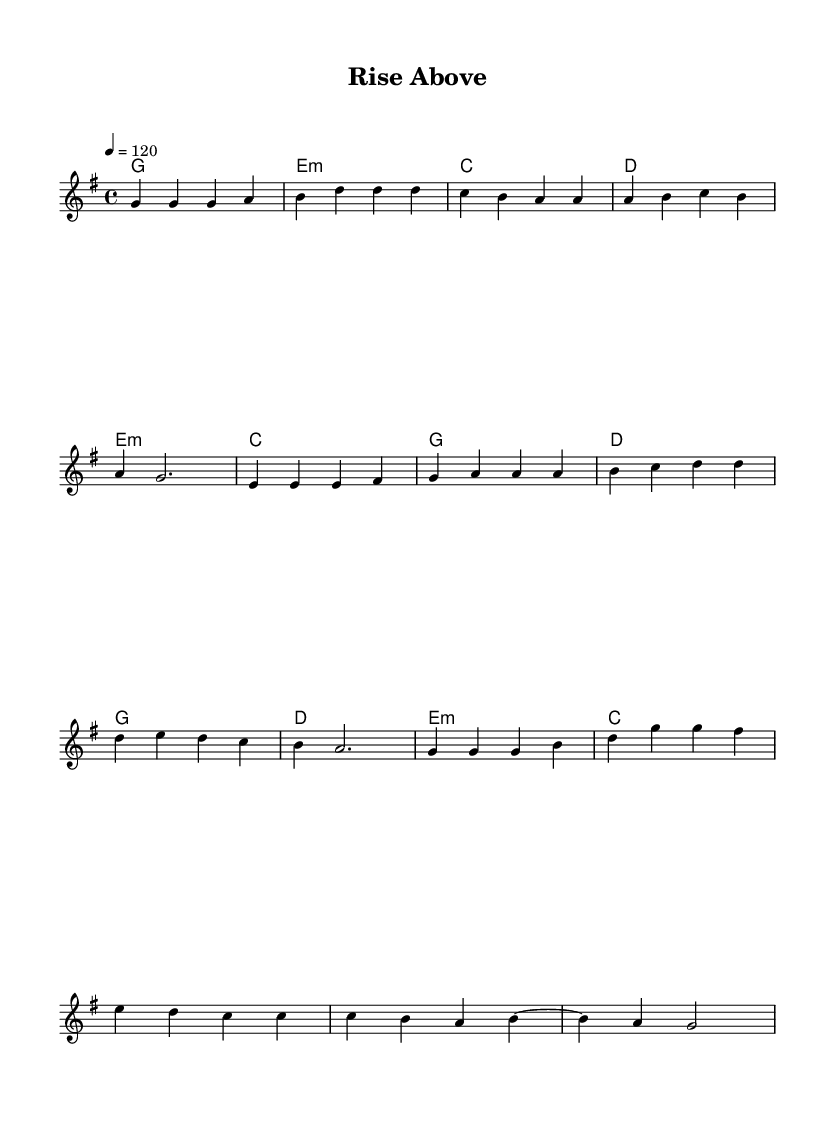What is the key signature of this music? The key signature is indicated at the beginning of the staff, and it shows one sharp, which corresponds to G major.
Answer: G major What is the time signature? The time signature is indicated at the start of the score, where it shows four beats per measure, denoted as 4/4.
Answer: 4/4 What is the tempo marking? The tempo is marked at the beginning as a quarter note = 120, indicating how fast the piece should be played.
Answer: 120 How many measures are there in the chorus? By counting the measures in the chorus section from the score, there are four measures.
Answer: 4 What harmonies are used in the pre-chorus? The pre-chorus has the following harmonies: E minor, C major, G major, and D major. This can be found by examining the chord symbols written above the melody.
Answer: E minor, C, G, D Which section includes the lyrics 'rise above'? This phrase likely falls within the chorus section, based on common pop song structure, which usually features the main message repeated in the chorus.
Answer: Chorus What is the last note of the melody? The last note of the melody is indicated at the end of the score, showing a G note on the beat of the last measure.
Answer: G 